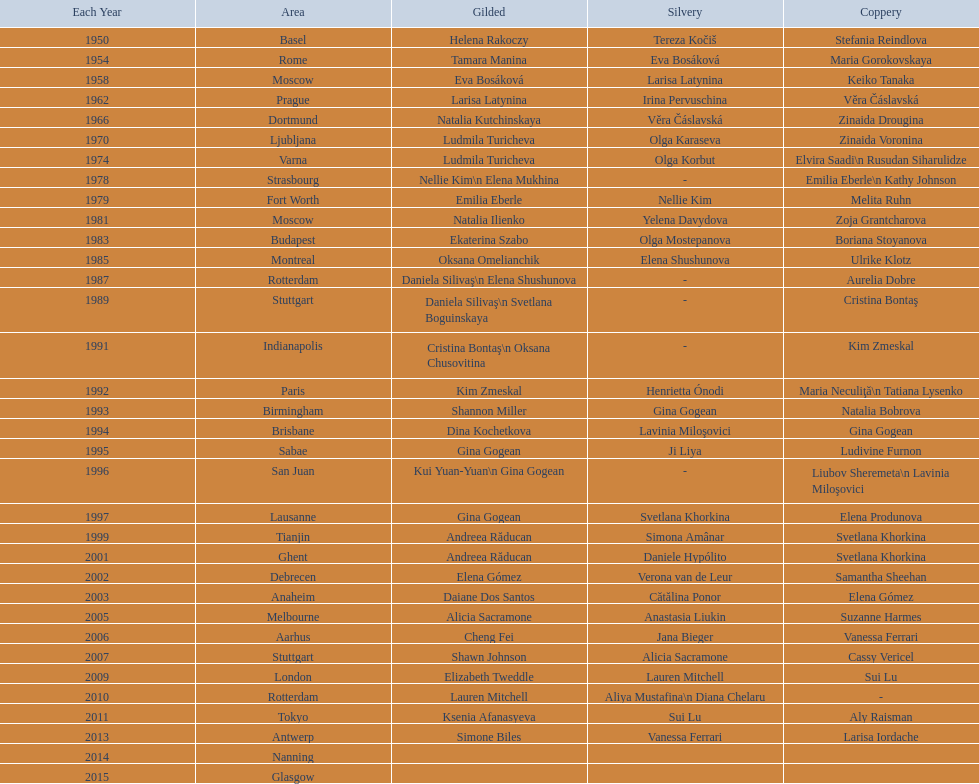Which two american rivals won consecutive floor exercise gold medals at the artistic gymnastics world championships in 1992 and 1993? Kim Zmeskal, Shannon Miller. 